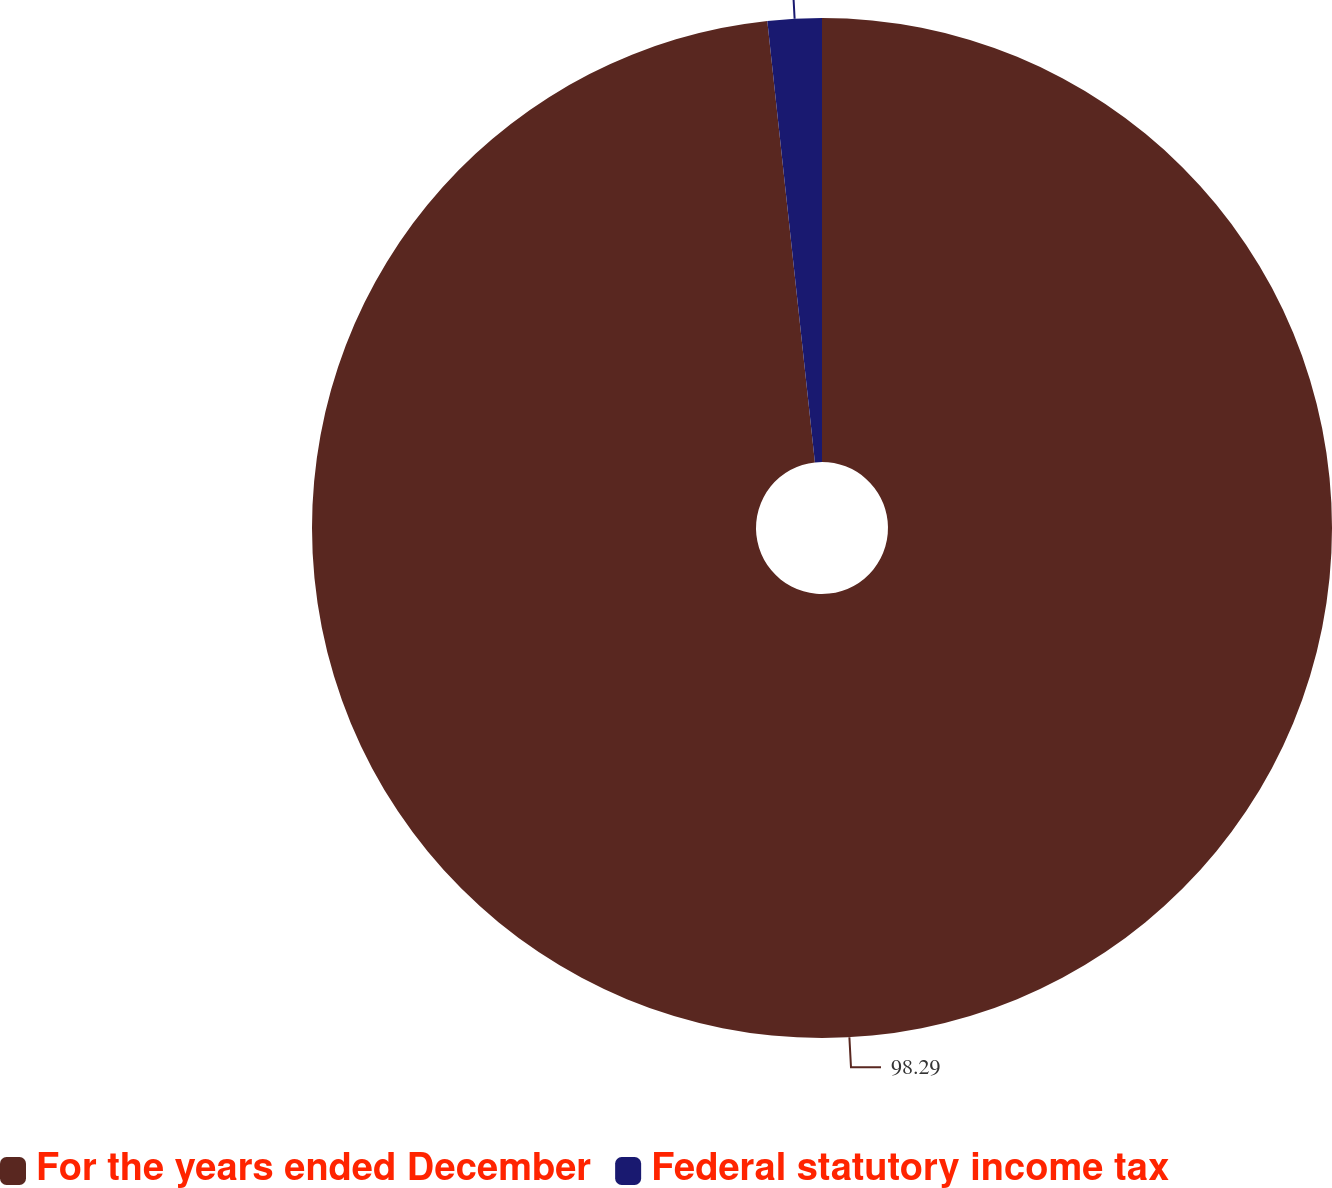<chart> <loc_0><loc_0><loc_500><loc_500><pie_chart><fcel>For the years ended December<fcel>Federal statutory income tax<nl><fcel>98.29%<fcel>1.71%<nl></chart> 